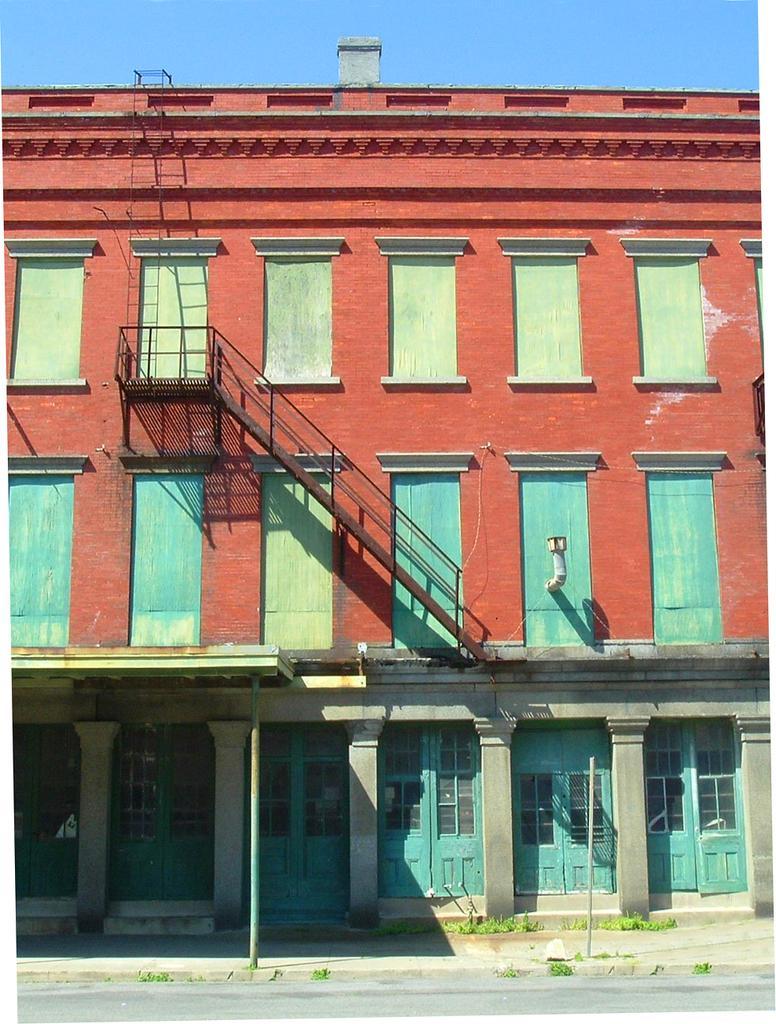In one or two sentences, can you explain what this image depicts? In this image we can see a front view of a building, in this image we can see a metal staircase to the top. 